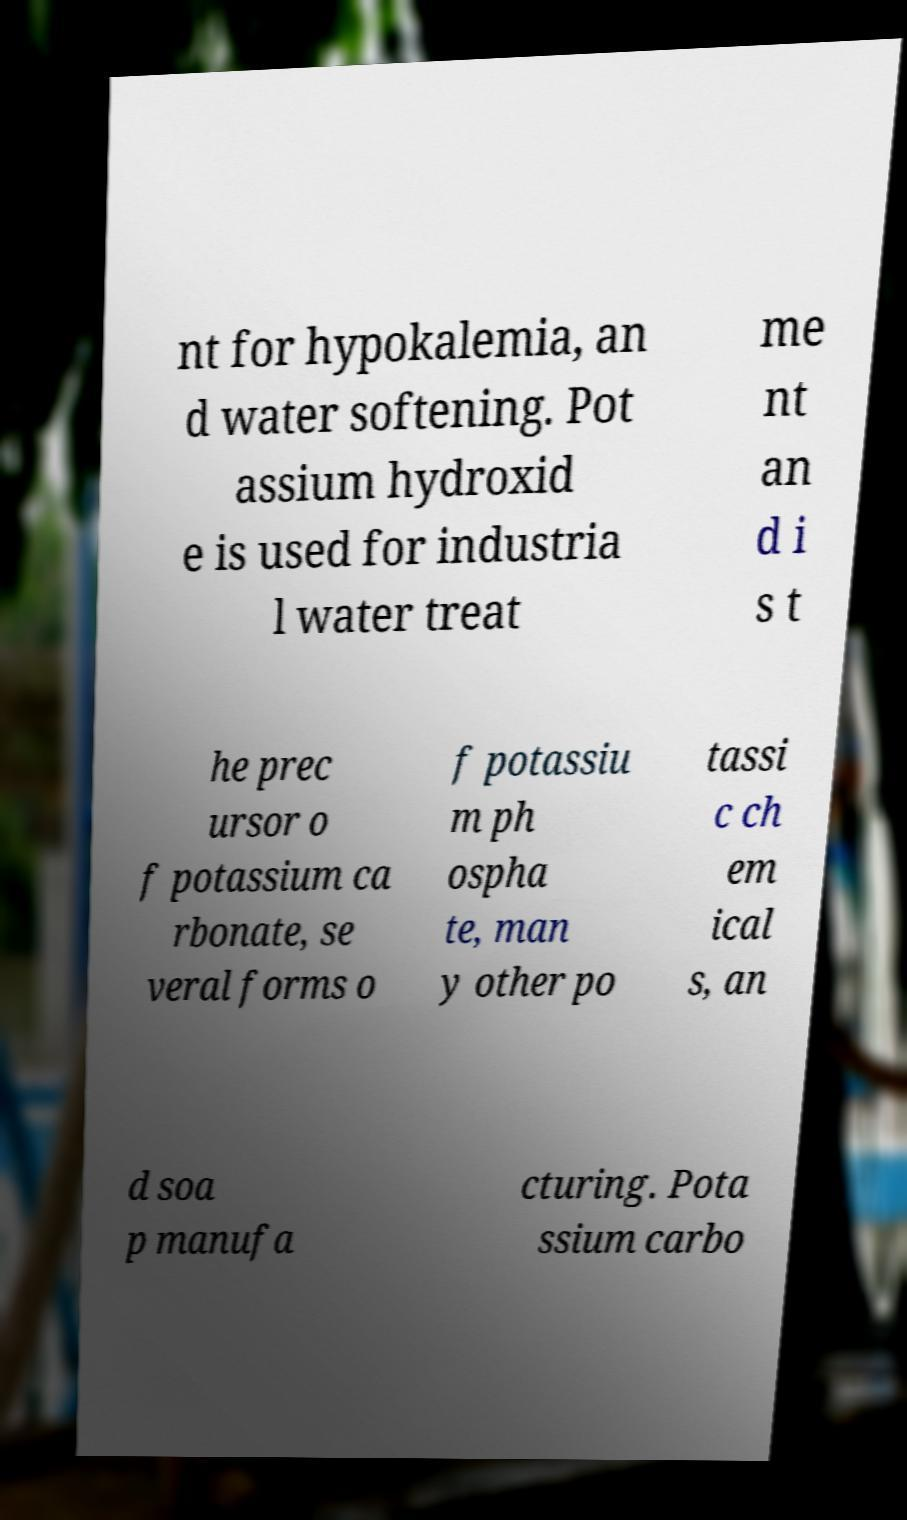Could you assist in decoding the text presented in this image and type it out clearly? nt for hypokalemia, an d water softening. Pot assium hydroxid e is used for industria l water treat me nt an d i s t he prec ursor o f potassium ca rbonate, se veral forms o f potassiu m ph ospha te, man y other po tassi c ch em ical s, an d soa p manufa cturing. Pota ssium carbo 